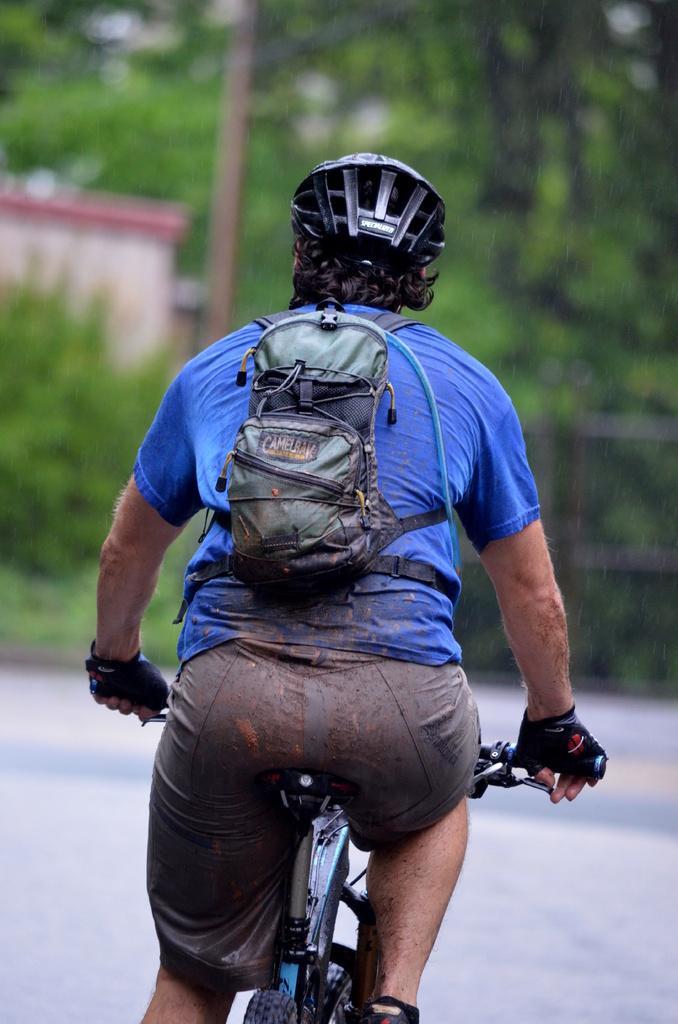Describe this image in one or two sentences. In this image there is a person riding a bicycle in the street by wearing a back pack , and a helmet and the back ground there is house, plants, trees, pole. 